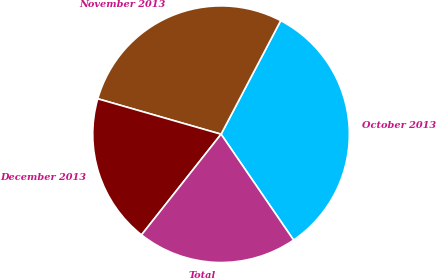Convert chart to OTSL. <chart><loc_0><loc_0><loc_500><loc_500><pie_chart><fcel>October 2013<fcel>November 2013<fcel>December 2013<fcel>Total<nl><fcel>32.74%<fcel>28.24%<fcel>18.81%<fcel>20.2%<nl></chart> 